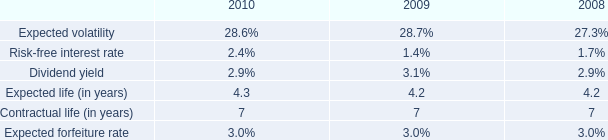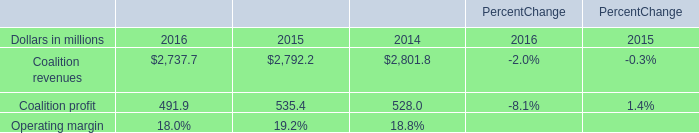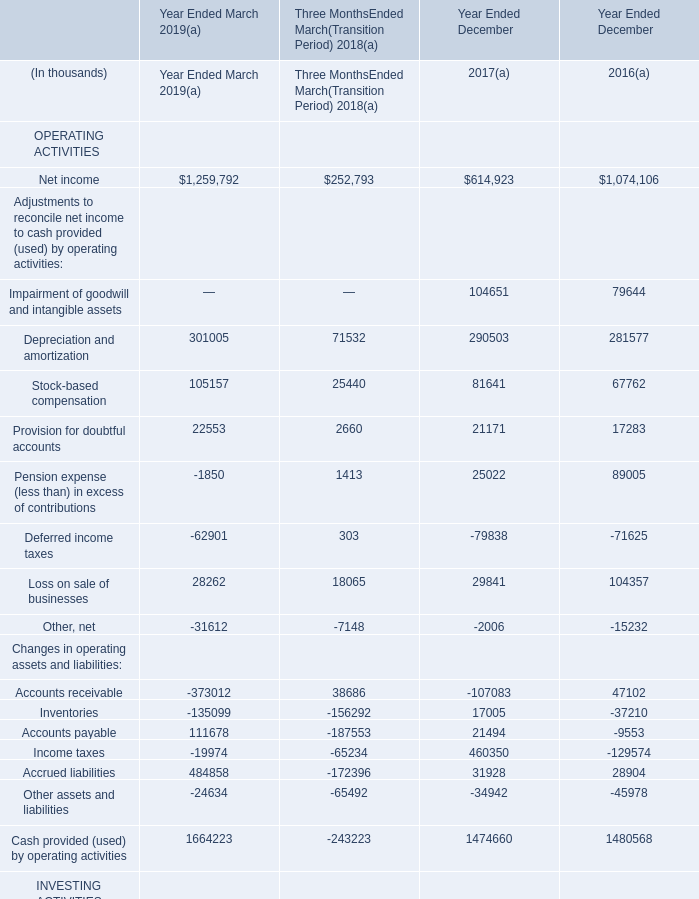What's the greatest value of Balances per Consolidated Balance Sheets in 2019? 
Answer: cash and cash equivalent. 